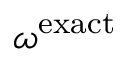<formula> <loc_0><loc_0><loc_500><loc_500>\omega ^ { e x a c t }</formula> 